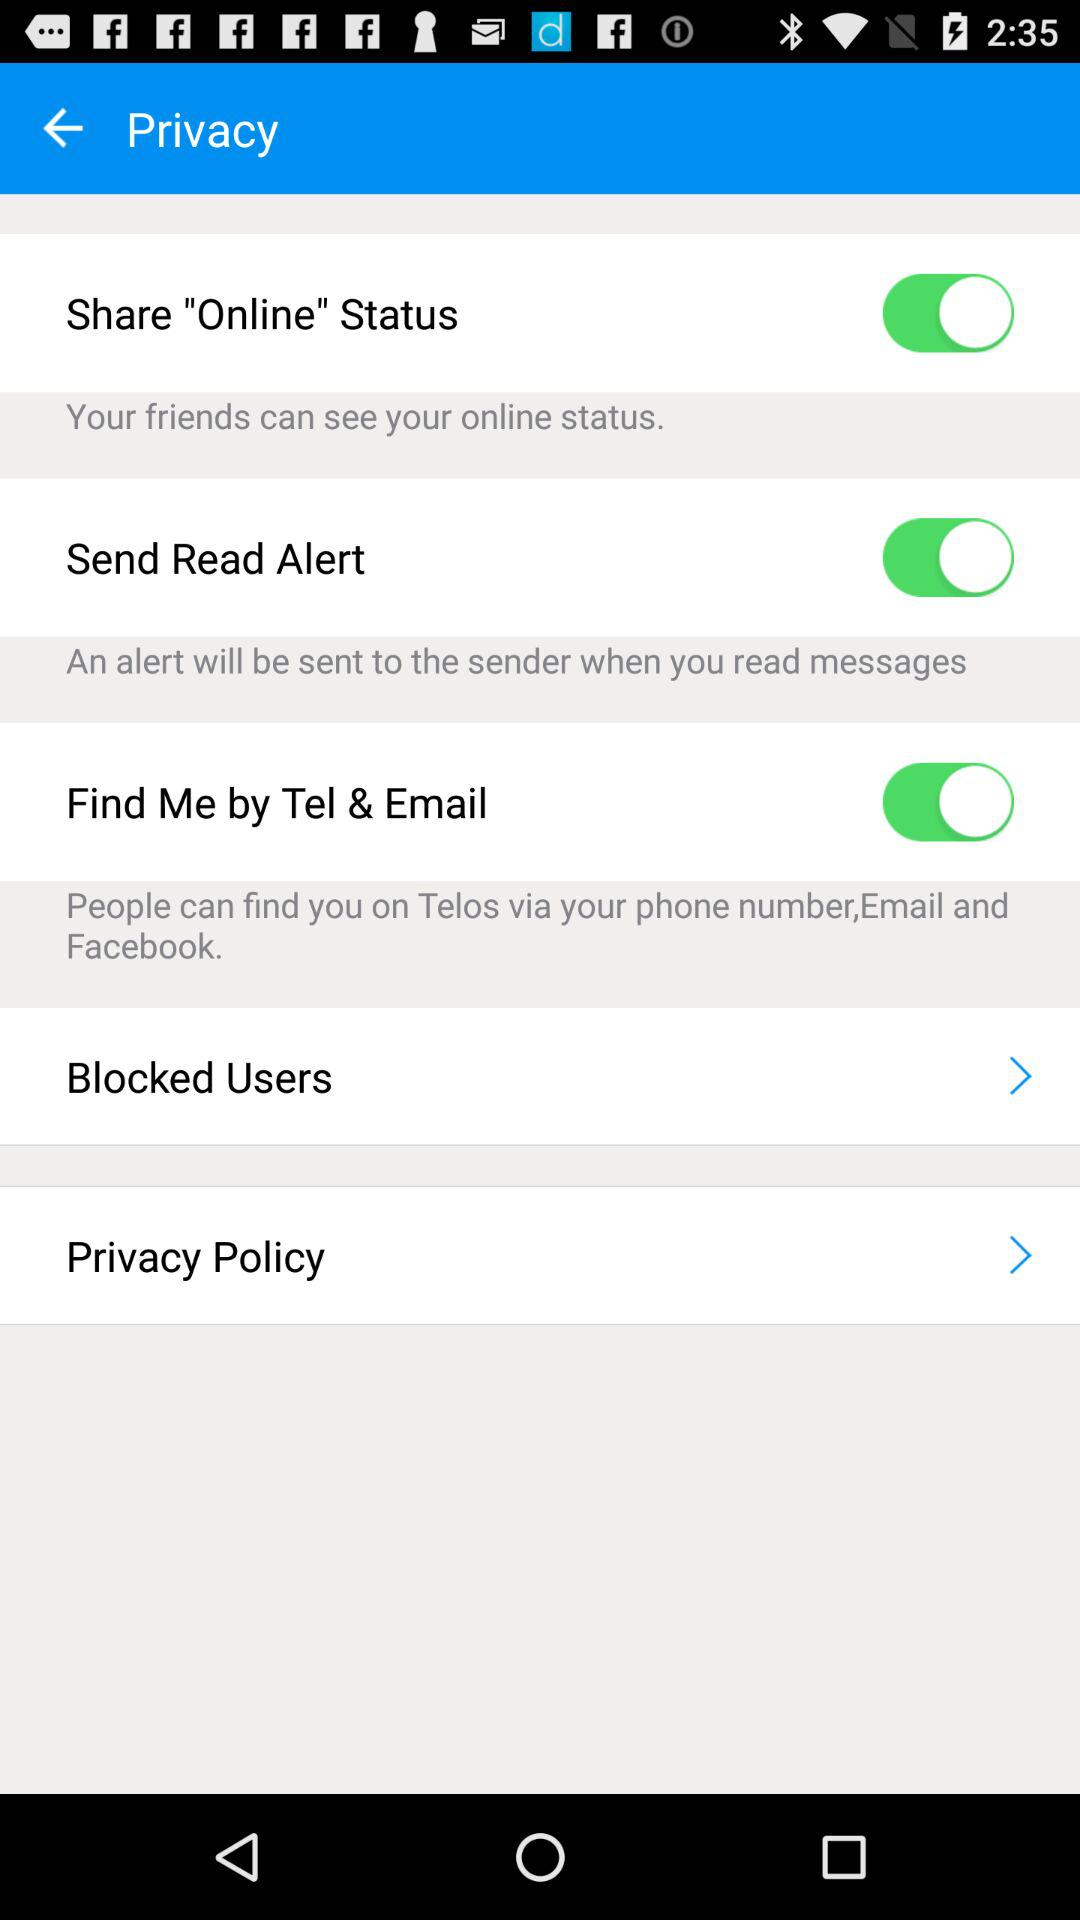When will we get a read alert? Based on the image, you will receive a read alert when someone sends you a message and you read it. The setting 'Send Read Alert' appears to be enabled, indicating that this feature is currently active. If you view or engage with received messages, the system will automatically notify the sender that you have read their message. 